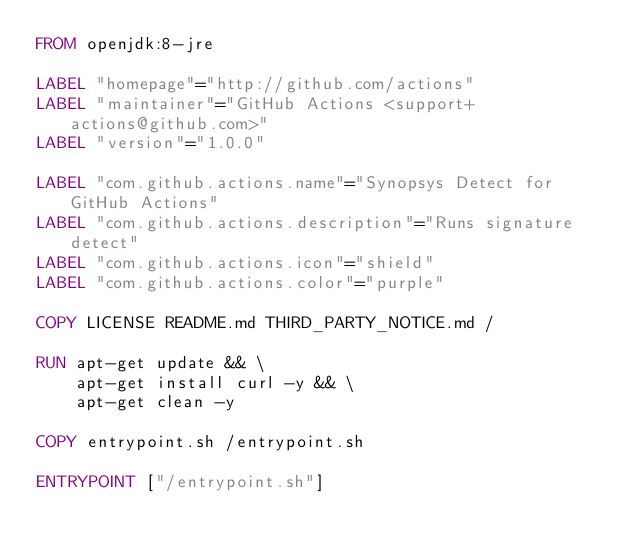<code> <loc_0><loc_0><loc_500><loc_500><_Dockerfile_>FROM openjdk:8-jre

LABEL "homepage"="http://github.com/actions"
LABEL "maintainer"="GitHub Actions <support+actions@github.com>"
LABEL "version"="1.0.0"

LABEL "com.github.actions.name"="Synopsys Detect for GitHub Actions"
LABEL "com.github.actions.description"="Runs signature detect"
LABEL "com.github.actions.icon"="shield"
LABEL "com.github.actions.color"="purple"

COPY LICENSE README.md THIRD_PARTY_NOTICE.md /

RUN apt-get update && \
    apt-get install curl -y && \
    apt-get clean -y

COPY entrypoint.sh /entrypoint.sh

ENTRYPOINT ["/entrypoint.sh"]
</code> 